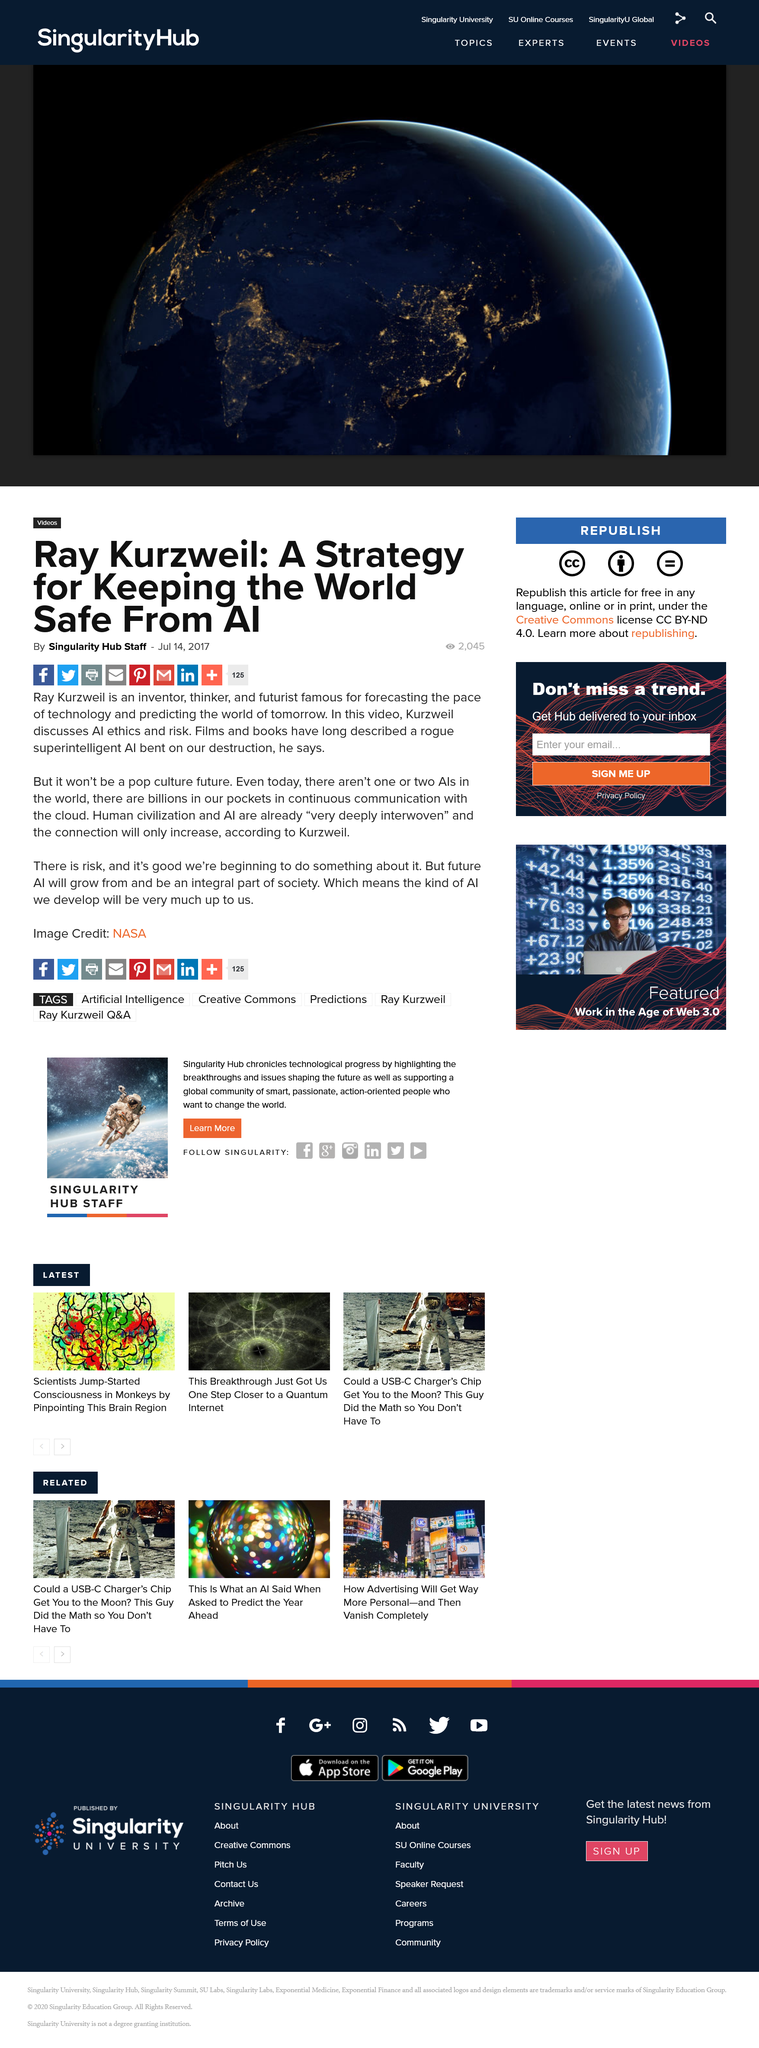Give some essential details in this illustration. Ray Kurzweil is widely recognized for his prolific contributions to the fields of technology and futurism, particularly for his predictions on the rapid advancement of technology and the shape of tomorrow's world. On July 14, 2017, the article "Ray Kurzweil: A Strategy for Keeping the World Safe From AI" was published. In the video mentioned here, Ray Kurzweil discusses AI ethics and risk, providing insights and perspectives on the potential consequences of artificial intelligence. 